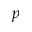Convert formula to latex. <formula><loc_0><loc_0><loc_500><loc_500>p</formula> 